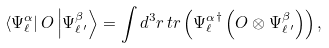<formula> <loc_0><loc_0><loc_500><loc_500>\left < { \Psi _ { \ell } ^ { \alpha } } \right | O \left | \Psi _ { \ell \, ^ { \prime } } ^ { \beta } \right > = \int d ^ { 3 } r \, t r \left ( { \Psi _ { \ell } ^ { \alpha } } ^ { \dagger } \left ( O \otimes \Psi _ { \ell \, ^ { \prime } } ^ { \beta } \right ) \right ) ,</formula> 